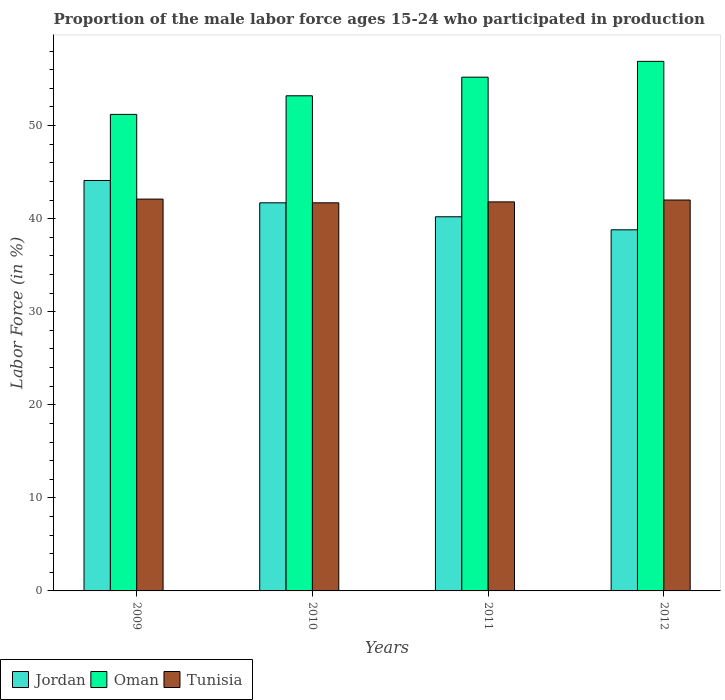How many different coloured bars are there?
Your answer should be compact. 3. How many groups of bars are there?
Provide a succinct answer. 4. Are the number of bars per tick equal to the number of legend labels?
Provide a succinct answer. Yes. Are the number of bars on each tick of the X-axis equal?
Provide a succinct answer. Yes. How many bars are there on the 1st tick from the left?
Offer a terse response. 3. In how many cases, is the number of bars for a given year not equal to the number of legend labels?
Your answer should be compact. 0. What is the proportion of the male labor force who participated in production in Tunisia in 2010?
Give a very brief answer. 41.7. Across all years, what is the maximum proportion of the male labor force who participated in production in Oman?
Provide a short and direct response. 56.9. Across all years, what is the minimum proportion of the male labor force who participated in production in Jordan?
Make the answer very short. 38.8. In which year was the proportion of the male labor force who participated in production in Jordan minimum?
Offer a terse response. 2012. What is the total proportion of the male labor force who participated in production in Tunisia in the graph?
Provide a succinct answer. 167.6. What is the difference between the proportion of the male labor force who participated in production in Oman in 2011 and that in 2012?
Keep it short and to the point. -1.7. What is the difference between the proportion of the male labor force who participated in production in Oman in 2011 and the proportion of the male labor force who participated in production in Jordan in 2012?
Keep it short and to the point. 16.4. What is the average proportion of the male labor force who participated in production in Oman per year?
Keep it short and to the point. 54.13. In the year 2011, what is the difference between the proportion of the male labor force who participated in production in Jordan and proportion of the male labor force who participated in production in Oman?
Give a very brief answer. -15. In how many years, is the proportion of the male labor force who participated in production in Oman greater than 56 %?
Your response must be concise. 1. What is the ratio of the proportion of the male labor force who participated in production in Tunisia in 2009 to that in 2011?
Your response must be concise. 1.01. Is the proportion of the male labor force who participated in production in Oman in 2010 less than that in 2012?
Give a very brief answer. Yes. What is the difference between the highest and the second highest proportion of the male labor force who participated in production in Jordan?
Keep it short and to the point. 2.4. What is the difference between the highest and the lowest proportion of the male labor force who participated in production in Tunisia?
Offer a terse response. 0.4. What does the 3rd bar from the left in 2010 represents?
Keep it short and to the point. Tunisia. What does the 3rd bar from the right in 2012 represents?
Give a very brief answer. Jordan. Is it the case that in every year, the sum of the proportion of the male labor force who participated in production in Oman and proportion of the male labor force who participated in production in Jordan is greater than the proportion of the male labor force who participated in production in Tunisia?
Offer a terse response. Yes. Are all the bars in the graph horizontal?
Ensure brevity in your answer.  No. Are the values on the major ticks of Y-axis written in scientific E-notation?
Your answer should be compact. No. Does the graph contain any zero values?
Give a very brief answer. No. Does the graph contain grids?
Your response must be concise. No. Where does the legend appear in the graph?
Offer a very short reply. Bottom left. How many legend labels are there?
Make the answer very short. 3. What is the title of the graph?
Keep it short and to the point. Proportion of the male labor force ages 15-24 who participated in production. Does "Brunei Darussalam" appear as one of the legend labels in the graph?
Your answer should be very brief. No. What is the label or title of the Y-axis?
Provide a succinct answer. Labor Force (in %). What is the Labor Force (in %) in Jordan in 2009?
Your answer should be compact. 44.1. What is the Labor Force (in %) in Oman in 2009?
Keep it short and to the point. 51.2. What is the Labor Force (in %) in Tunisia in 2009?
Give a very brief answer. 42.1. What is the Labor Force (in %) in Jordan in 2010?
Give a very brief answer. 41.7. What is the Labor Force (in %) of Oman in 2010?
Your answer should be very brief. 53.2. What is the Labor Force (in %) in Tunisia in 2010?
Your response must be concise. 41.7. What is the Labor Force (in %) in Jordan in 2011?
Provide a short and direct response. 40.2. What is the Labor Force (in %) of Oman in 2011?
Offer a very short reply. 55.2. What is the Labor Force (in %) in Tunisia in 2011?
Make the answer very short. 41.8. What is the Labor Force (in %) in Jordan in 2012?
Keep it short and to the point. 38.8. What is the Labor Force (in %) in Oman in 2012?
Provide a short and direct response. 56.9. Across all years, what is the maximum Labor Force (in %) of Jordan?
Make the answer very short. 44.1. Across all years, what is the maximum Labor Force (in %) of Oman?
Make the answer very short. 56.9. Across all years, what is the maximum Labor Force (in %) in Tunisia?
Provide a succinct answer. 42.1. Across all years, what is the minimum Labor Force (in %) of Jordan?
Offer a terse response. 38.8. Across all years, what is the minimum Labor Force (in %) in Oman?
Your answer should be very brief. 51.2. Across all years, what is the minimum Labor Force (in %) of Tunisia?
Provide a succinct answer. 41.7. What is the total Labor Force (in %) in Jordan in the graph?
Your answer should be compact. 164.8. What is the total Labor Force (in %) in Oman in the graph?
Ensure brevity in your answer.  216.5. What is the total Labor Force (in %) in Tunisia in the graph?
Make the answer very short. 167.6. What is the difference between the Labor Force (in %) in Jordan in 2009 and that in 2010?
Ensure brevity in your answer.  2.4. What is the difference between the Labor Force (in %) of Oman in 2009 and that in 2010?
Offer a terse response. -2. What is the difference between the Labor Force (in %) in Jordan in 2009 and that in 2011?
Ensure brevity in your answer.  3.9. What is the difference between the Labor Force (in %) in Oman in 2009 and that in 2011?
Offer a very short reply. -4. What is the difference between the Labor Force (in %) of Tunisia in 2009 and that in 2011?
Keep it short and to the point. 0.3. What is the difference between the Labor Force (in %) of Oman in 2009 and that in 2012?
Offer a terse response. -5.7. What is the difference between the Labor Force (in %) in Jordan in 2010 and that in 2011?
Your answer should be very brief. 1.5. What is the difference between the Labor Force (in %) of Oman in 2010 and that in 2011?
Make the answer very short. -2. What is the difference between the Labor Force (in %) of Tunisia in 2010 and that in 2011?
Provide a succinct answer. -0.1. What is the difference between the Labor Force (in %) in Oman in 2010 and that in 2012?
Your answer should be very brief. -3.7. What is the difference between the Labor Force (in %) in Jordan in 2011 and that in 2012?
Offer a terse response. 1.4. What is the difference between the Labor Force (in %) in Oman in 2011 and that in 2012?
Provide a succinct answer. -1.7. What is the difference between the Labor Force (in %) in Tunisia in 2011 and that in 2012?
Make the answer very short. -0.2. What is the difference between the Labor Force (in %) of Jordan in 2009 and the Labor Force (in %) of Oman in 2010?
Your response must be concise. -9.1. What is the difference between the Labor Force (in %) of Oman in 2009 and the Labor Force (in %) of Tunisia in 2010?
Offer a terse response. 9.5. What is the difference between the Labor Force (in %) in Oman in 2009 and the Labor Force (in %) in Tunisia in 2011?
Offer a terse response. 9.4. What is the difference between the Labor Force (in %) of Jordan in 2009 and the Labor Force (in %) of Tunisia in 2012?
Provide a short and direct response. 2.1. What is the difference between the Labor Force (in %) of Jordan in 2010 and the Labor Force (in %) of Tunisia in 2011?
Offer a terse response. -0.1. What is the difference between the Labor Force (in %) of Jordan in 2010 and the Labor Force (in %) of Oman in 2012?
Give a very brief answer. -15.2. What is the difference between the Labor Force (in %) of Jordan in 2010 and the Labor Force (in %) of Tunisia in 2012?
Make the answer very short. -0.3. What is the difference between the Labor Force (in %) in Oman in 2010 and the Labor Force (in %) in Tunisia in 2012?
Your answer should be compact. 11.2. What is the difference between the Labor Force (in %) of Jordan in 2011 and the Labor Force (in %) of Oman in 2012?
Offer a terse response. -16.7. What is the difference between the Labor Force (in %) of Jordan in 2011 and the Labor Force (in %) of Tunisia in 2012?
Give a very brief answer. -1.8. What is the average Labor Force (in %) of Jordan per year?
Offer a very short reply. 41.2. What is the average Labor Force (in %) in Oman per year?
Provide a short and direct response. 54.12. What is the average Labor Force (in %) of Tunisia per year?
Make the answer very short. 41.9. In the year 2009, what is the difference between the Labor Force (in %) in Jordan and Labor Force (in %) in Tunisia?
Make the answer very short. 2. In the year 2011, what is the difference between the Labor Force (in %) of Oman and Labor Force (in %) of Tunisia?
Offer a very short reply. 13.4. In the year 2012, what is the difference between the Labor Force (in %) of Jordan and Labor Force (in %) of Oman?
Keep it short and to the point. -18.1. In the year 2012, what is the difference between the Labor Force (in %) in Jordan and Labor Force (in %) in Tunisia?
Your answer should be very brief. -3.2. In the year 2012, what is the difference between the Labor Force (in %) in Oman and Labor Force (in %) in Tunisia?
Make the answer very short. 14.9. What is the ratio of the Labor Force (in %) of Jordan in 2009 to that in 2010?
Your answer should be compact. 1.06. What is the ratio of the Labor Force (in %) in Oman in 2009 to that in 2010?
Offer a very short reply. 0.96. What is the ratio of the Labor Force (in %) in Tunisia in 2009 to that in 2010?
Provide a short and direct response. 1.01. What is the ratio of the Labor Force (in %) of Jordan in 2009 to that in 2011?
Provide a succinct answer. 1.1. What is the ratio of the Labor Force (in %) of Oman in 2009 to that in 2011?
Give a very brief answer. 0.93. What is the ratio of the Labor Force (in %) in Tunisia in 2009 to that in 2011?
Your answer should be very brief. 1.01. What is the ratio of the Labor Force (in %) of Jordan in 2009 to that in 2012?
Give a very brief answer. 1.14. What is the ratio of the Labor Force (in %) of Oman in 2009 to that in 2012?
Offer a very short reply. 0.9. What is the ratio of the Labor Force (in %) in Tunisia in 2009 to that in 2012?
Your answer should be compact. 1. What is the ratio of the Labor Force (in %) in Jordan in 2010 to that in 2011?
Ensure brevity in your answer.  1.04. What is the ratio of the Labor Force (in %) of Oman in 2010 to that in 2011?
Make the answer very short. 0.96. What is the ratio of the Labor Force (in %) in Jordan in 2010 to that in 2012?
Provide a short and direct response. 1.07. What is the ratio of the Labor Force (in %) of Oman in 2010 to that in 2012?
Give a very brief answer. 0.94. What is the ratio of the Labor Force (in %) in Tunisia in 2010 to that in 2012?
Make the answer very short. 0.99. What is the ratio of the Labor Force (in %) of Jordan in 2011 to that in 2012?
Your response must be concise. 1.04. What is the ratio of the Labor Force (in %) of Oman in 2011 to that in 2012?
Your response must be concise. 0.97. What is the ratio of the Labor Force (in %) in Tunisia in 2011 to that in 2012?
Provide a short and direct response. 1. What is the difference between the highest and the second highest Labor Force (in %) in Tunisia?
Your answer should be very brief. 0.1. What is the difference between the highest and the lowest Labor Force (in %) in Jordan?
Give a very brief answer. 5.3. What is the difference between the highest and the lowest Labor Force (in %) in Tunisia?
Your answer should be very brief. 0.4. 